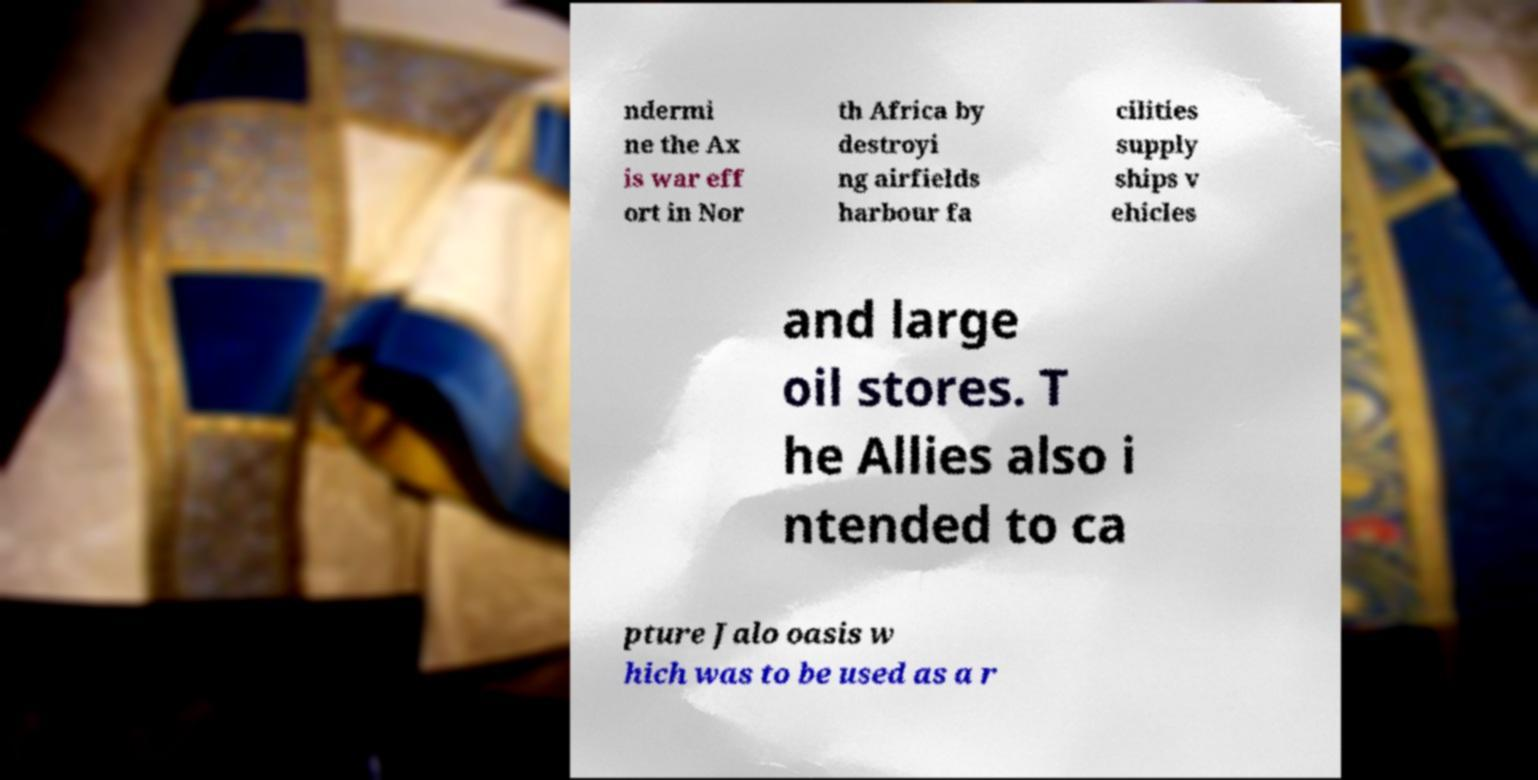There's text embedded in this image that I need extracted. Can you transcribe it verbatim? ndermi ne the Ax is war eff ort in Nor th Africa by destroyi ng airfields harbour fa cilities supply ships v ehicles and large oil stores. T he Allies also i ntended to ca pture Jalo oasis w hich was to be used as a r 